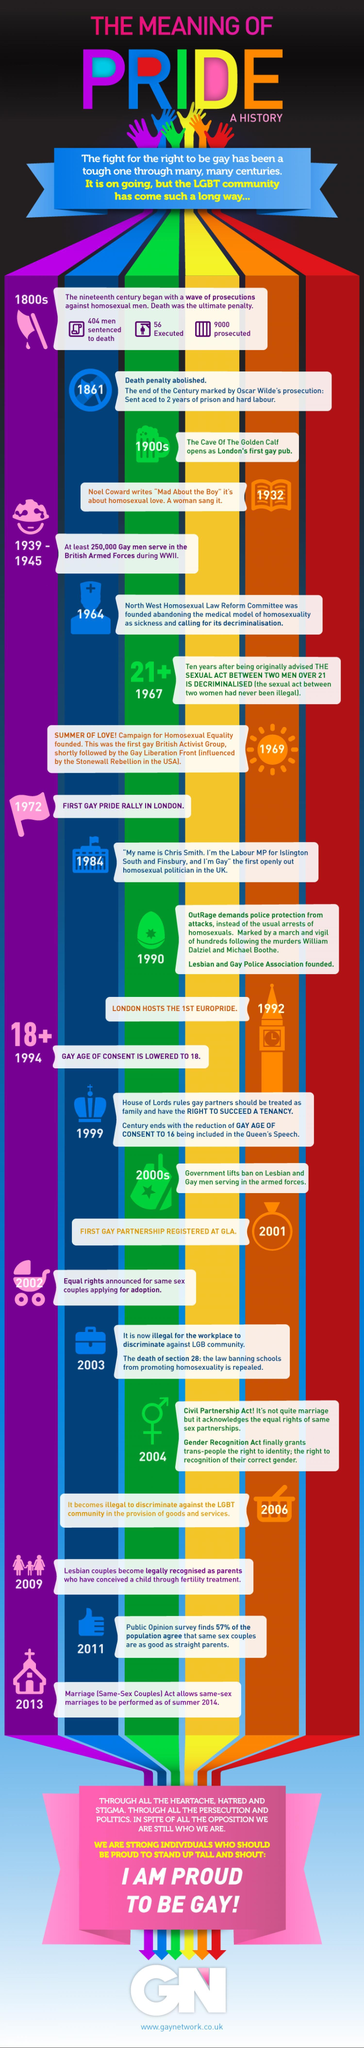How many homosexual men were prosecuted in the 1800s?
Answer the question with a short phrase. 9000 How many homosexual men were executed in the 1800s? 56 When did House of Lords approve tenancy rights to gay partners? 1999 When was the committee that called to decriminalise homosexuality founded? 1964 How many homosexual men were sentenced to death in the 1800s? 404 When was Campaign for Homosexual Equality founded? 1969 